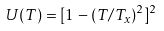Convert formula to latex. <formula><loc_0><loc_0><loc_500><loc_500>U ( T ) = [ 1 - ( T / T _ { x } ) ^ { 2 } ] ^ { 2 }</formula> 